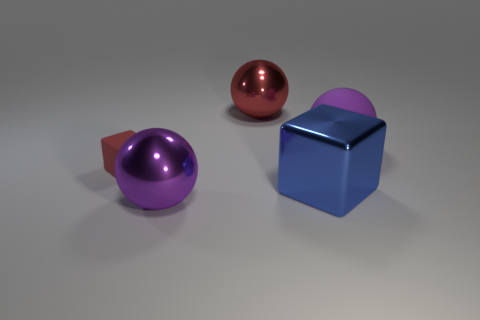Subtract all cyan blocks. Subtract all yellow balls. How many blocks are left? 2 Add 2 red balls. How many objects exist? 7 Subtract all blocks. How many objects are left? 3 Subtract 0 green cubes. How many objects are left? 5 Subtract all small yellow cylinders. Subtract all red spheres. How many objects are left? 4 Add 1 red matte objects. How many red matte objects are left? 2 Add 1 tiny brown rubber cubes. How many tiny brown rubber cubes exist? 1 